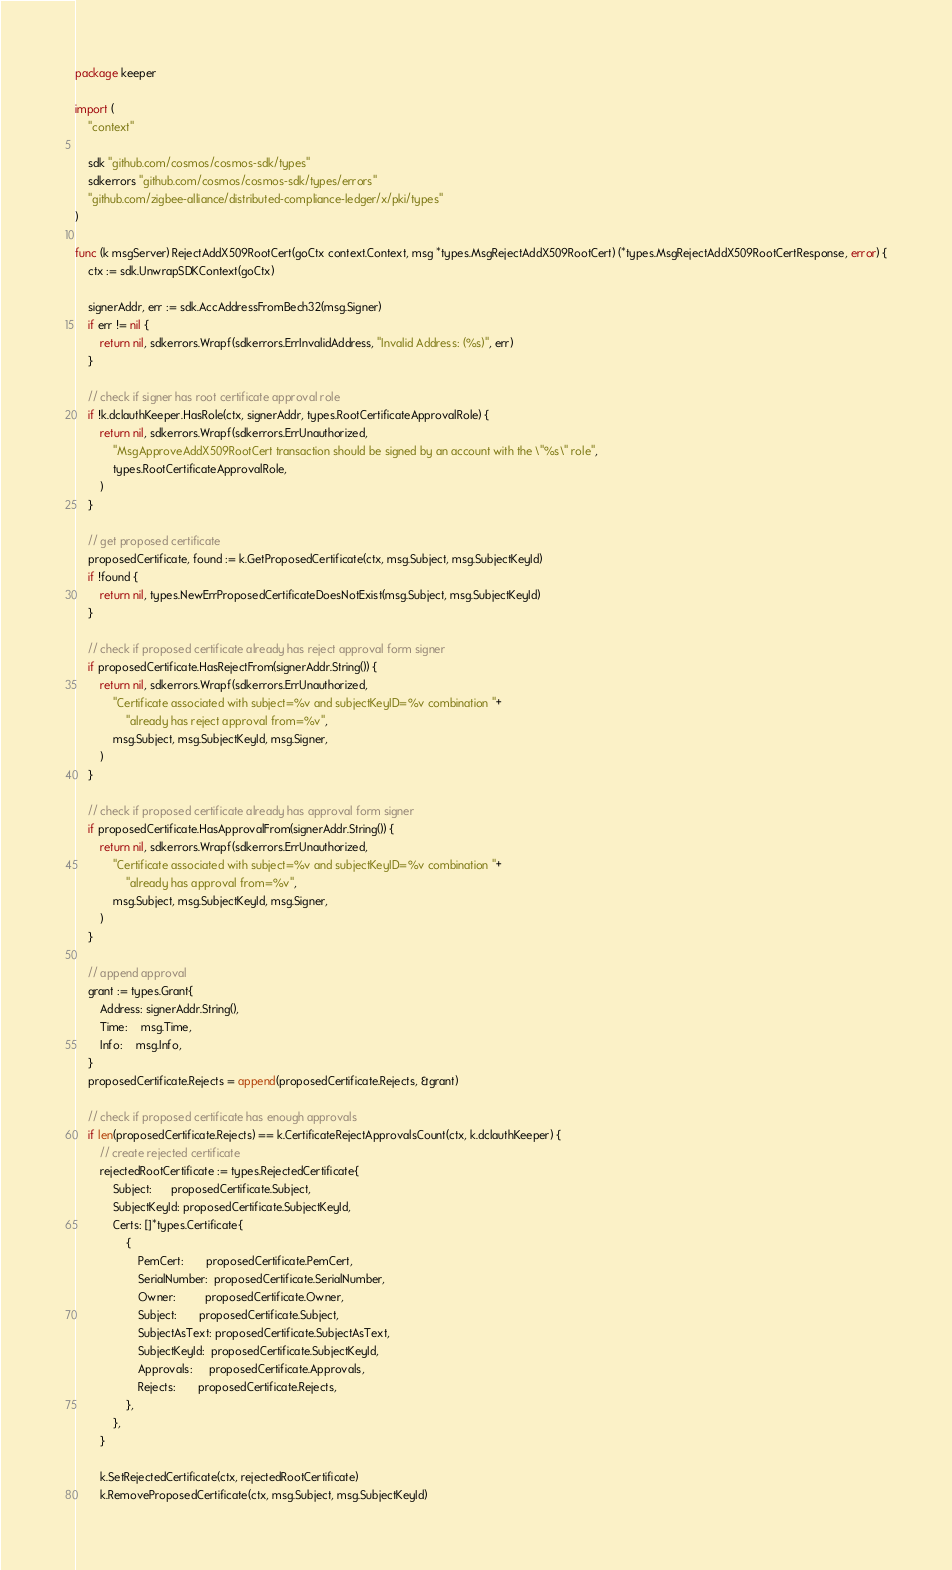Convert code to text. <code><loc_0><loc_0><loc_500><loc_500><_Go_>package keeper

import (
	"context"

	sdk "github.com/cosmos/cosmos-sdk/types"
	sdkerrors "github.com/cosmos/cosmos-sdk/types/errors"
	"github.com/zigbee-alliance/distributed-compliance-ledger/x/pki/types"
)

func (k msgServer) RejectAddX509RootCert(goCtx context.Context, msg *types.MsgRejectAddX509RootCert) (*types.MsgRejectAddX509RootCertResponse, error) {
	ctx := sdk.UnwrapSDKContext(goCtx)

	signerAddr, err := sdk.AccAddressFromBech32(msg.Signer)
	if err != nil {
		return nil, sdkerrors.Wrapf(sdkerrors.ErrInvalidAddress, "Invalid Address: (%s)", err)
	}

	// check if signer has root certificate approval role
	if !k.dclauthKeeper.HasRole(ctx, signerAddr, types.RootCertificateApprovalRole) {
		return nil, sdkerrors.Wrapf(sdkerrors.ErrUnauthorized,
			"MsgApproveAddX509RootCert transaction should be signed by an account with the \"%s\" role",
			types.RootCertificateApprovalRole,
		)
	}

	// get proposed certificate
	proposedCertificate, found := k.GetProposedCertificate(ctx, msg.Subject, msg.SubjectKeyId)
	if !found {
		return nil, types.NewErrProposedCertificateDoesNotExist(msg.Subject, msg.SubjectKeyId)
	}

	// check if proposed certificate already has reject approval form signer
	if proposedCertificate.HasRejectFrom(signerAddr.String()) {
		return nil, sdkerrors.Wrapf(sdkerrors.ErrUnauthorized,
			"Certificate associated with subject=%v and subjectKeyID=%v combination "+
				"already has reject approval from=%v",
			msg.Subject, msg.SubjectKeyId, msg.Signer,
		)
	}

	// check if proposed certificate already has approval form signer
	if proposedCertificate.HasApprovalFrom(signerAddr.String()) {
		return nil, sdkerrors.Wrapf(sdkerrors.ErrUnauthorized,
			"Certificate associated with subject=%v and subjectKeyID=%v combination "+
				"already has approval from=%v",
			msg.Subject, msg.SubjectKeyId, msg.Signer,
		)
	}

	// append approval
	grant := types.Grant{
		Address: signerAddr.String(),
		Time:    msg.Time,
		Info:    msg.Info,
	}
	proposedCertificate.Rejects = append(proposedCertificate.Rejects, &grant)

	// check if proposed certificate has enough approvals
	if len(proposedCertificate.Rejects) == k.CertificateRejectApprovalsCount(ctx, k.dclauthKeeper) {
		// create rejected certificate
		rejectedRootCertificate := types.RejectedCertificate{
			Subject:      proposedCertificate.Subject,
			SubjectKeyId: proposedCertificate.SubjectKeyId,
			Certs: []*types.Certificate{
				{
					PemCert:       proposedCertificate.PemCert,
					SerialNumber:  proposedCertificate.SerialNumber,
					Owner:         proposedCertificate.Owner,
					Subject:       proposedCertificate.Subject,
					SubjectAsText: proposedCertificate.SubjectAsText,
					SubjectKeyId:  proposedCertificate.SubjectKeyId,
					Approvals:     proposedCertificate.Approvals,
					Rejects:       proposedCertificate.Rejects,
				},
			},
		}

		k.SetRejectedCertificate(ctx, rejectedRootCertificate)
		k.RemoveProposedCertificate(ctx, msg.Subject, msg.SubjectKeyId)</code> 